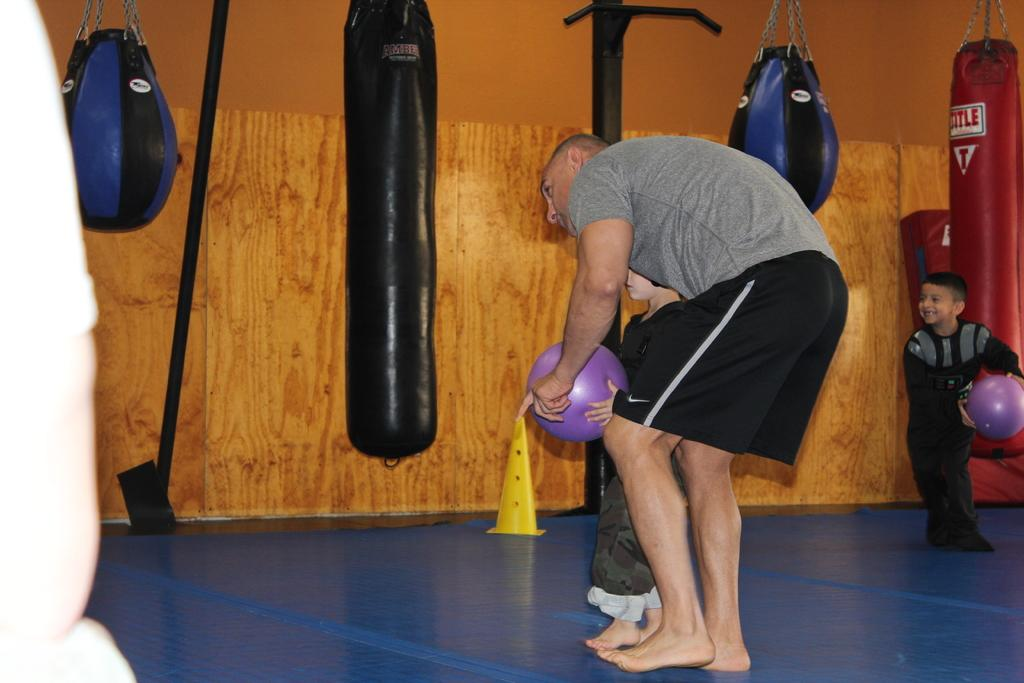Who is present in the image? There is a man and two boys in the image. What are the boys holding in the image? The boys are holding balls in the image. What type of sports equipment can be seen in the image? There are boxing speed balls and punching bags in the image. Are there any other items visible in the image? Yes, there are other items in the image. Where is the crate located in the image? There is no crate present in the image. How many women are visible in the image? There are no women visible in the image. 